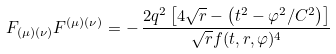<formula> <loc_0><loc_0><loc_500><loc_500>F _ { ( \mu ) ( \nu ) } F ^ { ( \mu ) ( \nu ) } = - \, \frac { 2 q ^ { 2 } \left [ 4 \sqrt { r } - \left ( t ^ { 2 } - \varphi ^ { 2 } / C ^ { 2 } \right ) \right ] } { \sqrt { r } f ( t , r , \varphi ) ^ { 4 } }</formula> 